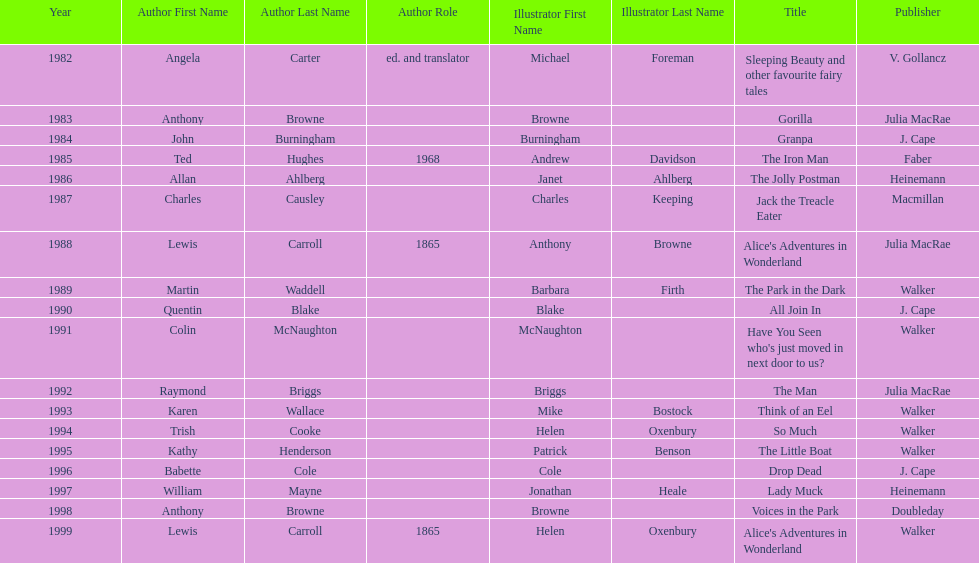How many titles had the same author listed as the illustrator? 7. 